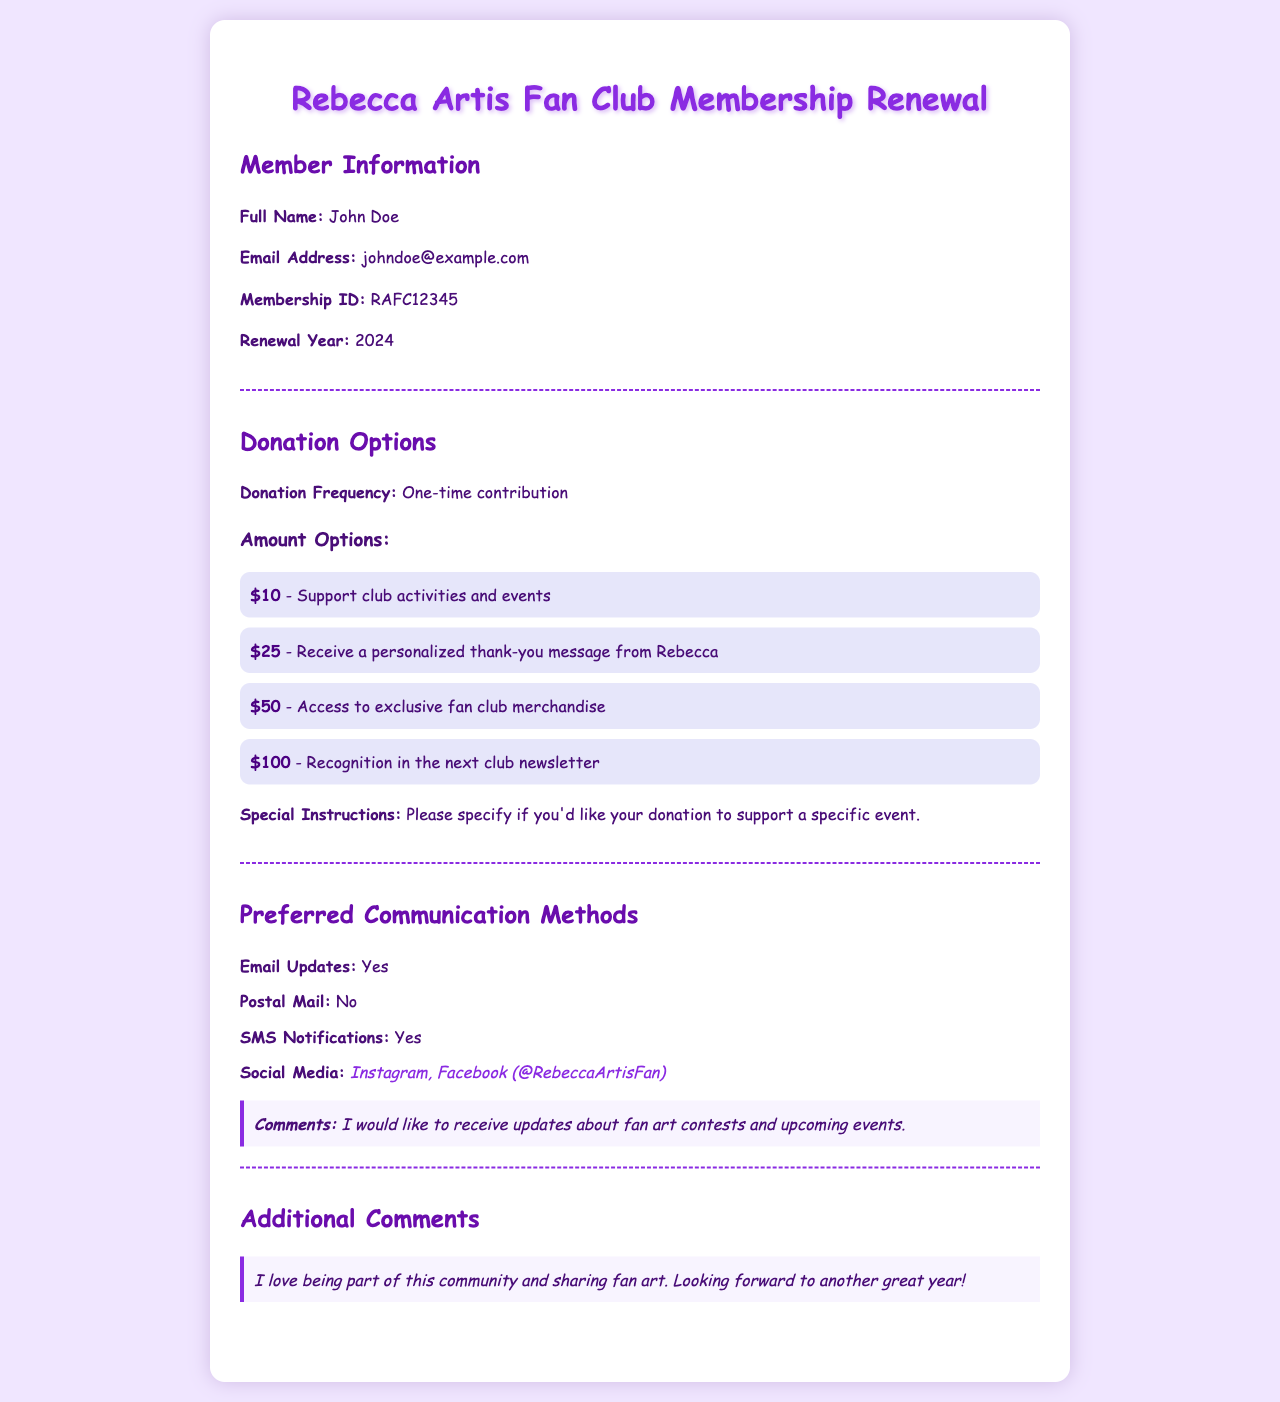What is the member's full name? The member's full name is listed in the document under Member Information.
Answer: John Doe What is the membership ID? The membership ID is specified clearly in the Member Information section of the document.
Answer: RAFC12345 What is the renewal year for the membership? The renewal year is mentioned in the Member Information section.
Answer: 2024 What donation frequency was selected? The chosen donation frequency is highlighted in the Donation Options section.
Answer: One-time contribution What is the highest donation amount listed? The highest donation amount is noted in the Donation Options section.
Answer: $100 What platform is mentioned for receiving social media updates? The preferred social media platforms are specified under Communication Methods.
Answer: Instagram, Facebook How would the member like to be notified about fan art contests? The member has mentioned a specific interest regarding updates in the comments section.
Answer: I would like to receive updates about fan art contests and upcoming events What additional comments did the member provide about the community? The member shared their feelings about being part of the community in the Additional Comments section.
Answer: I love being part of this community and sharing fan art 